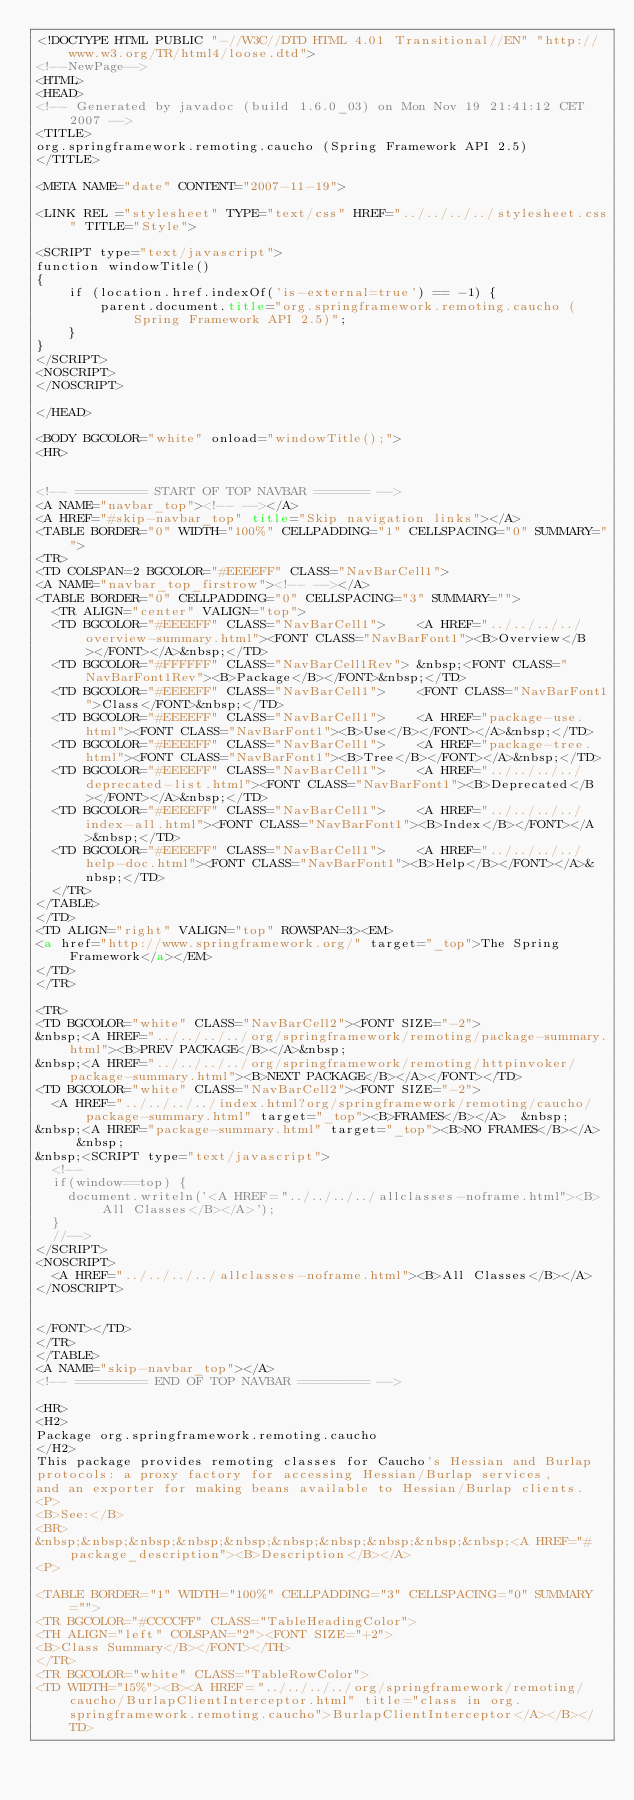<code> <loc_0><loc_0><loc_500><loc_500><_HTML_><!DOCTYPE HTML PUBLIC "-//W3C//DTD HTML 4.01 Transitional//EN" "http://www.w3.org/TR/html4/loose.dtd">
<!--NewPage-->
<HTML>
<HEAD>
<!-- Generated by javadoc (build 1.6.0_03) on Mon Nov 19 21:41:12 CET 2007 -->
<TITLE>
org.springframework.remoting.caucho (Spring Framework API 2.5)
</TITLE>

<META NAME="date" CONTENT="2007-11-19">

<LINK REL ="stylesheet" TYPE="text/css" HREF="../../../../stylesheet.css" TITLE="Style">

<SCRIPT type="text/javascript">
function windowTitle()
{
    if (location.href.indexOf('is-external=true') == -1) {
        parent.document.title="org.springframework.remoting.caucho (Spring Framework API 2.5)";
    }
}
</SCRIPT>
<NOSCRIPT>
</NOSCRIPT>

</HEAD>

<BODY BGCOLOR="white" onload="windowTitle();">
<HR>


<!-- ========= START OF TOP NAVBAR ======= -->
<A NAME="navbar_top"><!-- --></A>
<A HREF="#skip-navbar_top" title="Skip navigation links"></A>
<TABLE BORDER="0" WIDTH="100%" CELLPADDING="1" CELLSPACING="0" SUMMARY="">
<TR>
<TD COLSPAN=2 BGCOLOR="#EEEEFF" CLASS="NavBarCell1">
<A NAME="navbar_top_firstrow"><!-- --></A>
<TABLE BORDER="0" CELLPADDING="0" CELLSPACING="3" SUMMARY="">
  <TR ALIGN="center" VALIGN="top">
  <TD BGCOLOR="#EEEEFF" CLASS="NavBarCell1">    <A HREF="../../../../overview-summary.html"><FONT CLASS="NavBarFont1"><B>Overview</B></FONT></A>&nbsp;</TD>
  <TD BGCOLOR="#FFFFFF" CLASS="NavBarCell1Rev"> &nbsp;<FONT CLASS="NavBarFont1Rev"><B>Package</B></FONT>&nbsp;</TD>
  <TD BGCOLOR="#EEEEFF" CLASS="NavBarCell1">    <FONT CLASS="NavBarFont1">Class</FONT>&nbsp;</TD>
  <TD BGCOLOR="#EEEEFF" CLASS="NavBarCell1">    <A HREF="package-use.html"><FONT CLASS="NavBarFont1"><B>Use</B></FONT></A>&nbsp;</TD>
  <TD BGCOLOR="#EEEEFF" CLASS="NavBarCell1">    <A HREF="package-tree.html"><FONT CLASS="NavBarFont1"><B>Tree</B></FONT></A>&nbsp;</TD>
  <TD BGCOLOR="#EEEEFF" CLASS="NavBarCell1">    <A HREF="../../../../deprecated-list.html"><FONT CLASS="NavBarFont1"><B>Deprecated</B></FONT></A>&nbsp;</TD>
  <TD BGCOLOR="#EEEEFF" CLASS="NavBarCell1">    <A HREF="../../../../index-all.html"><FONT CLASS="NavBarFont1"><B>Index</B></FONT></A>&nbsp;</TD>
  <TD BGCOLOR="#EEEEFF" CLASS="NavBarCell1">    <A HREF="../../../../help-doc.html"><FONT CLASS="NavBarFont1"><B>Help</B></FONT></A>&nbsp;</TD>
  </TR>
</TABLE>
</TD>
<TD ALIGN="right" VALIGN="top" ROWSPAN=3><EM>
<a href="http://www.springframework.org/" target="_top">The Spring Framework</a></EM>
</TD>
</TR>

<TR>
<TD BGCOLOR="white" CLASS="NavBarCell2"><FONT SIZE="-2">
&nbsp;<A HREF="../../../../org/springframework/remoting/package-summary.html"><B>PREV PACKAGE</B></A>&nbsp;
&nbsp;<A HREF="../../../../org/springframework/remoting/httpinvoker/package-summary.html"><B>NEXT PACKAGE</B></A></FONT></TD>
<TD BGCOLOR="white" CLASS="NavBarCell2"><FONT SIZE="-2">
  <A HREF="../../../../index.html?org/springframework/remoting/caucho/package-summary.html" target="_top"><B>FRAMES</B></A>  &nbsp;
&nbsp;<A HREF="package-summary.html" target="_top"><B>NO FRAMES</B></A>  &nbsp;
&nbsp;<SCRIPT type="text/javascript">
  <!--
  if(window==top) {
    document.writeln('<A HREF="../../../../allclasses-noframe.html"><B>All Classes</B></A>');
  }
  //-->
</SCRIPT>
<NOSCRIPT>
  <A HREF="../../../../allclasses-noframe.html"><B>All Classes</B></A>
</NOSCRIPT>


</FONT></TD>
</TR>
</TABLE>
<A NAME="skip-navbar_top"></A>
<!-- ========= END OF TOP NAVBAR ========= -->

<HR>
<H2>
Package org.springframework.remoting.caucho
</H2>
This package provides remoting classes for Caucho's Hessian and Burlap
protocols: a proxy factory for accessing Hessian/Burlap services,
and an exporter for making beans available to Hessian/Burlap clients.
<P>
<B>See:</B>
<BR>
&nbsp;&nbsp;&nbsp;&nbsp;&nbsp;&nbsp;&nbsp;&nbsp;&nbsp;&nbsp;<A HREF="#package_description"><B>Description</B></A>
<P>

<TABLE BORDER="1" WIDTH="100%" CELLPADDING="3" CELLSPACING="0" SUMMARY="">
<TR BGCOLOR="#CCCCFF" CLASS="TableHeadingColor">
<TH ALIGN="left" COLSPAN="2"><FONT SIZE="+2">
<B>Class Summary</B></FONT></TH>
</TR>
<TR BGCOLOR="white" CLASS="TableRowColor">
<TD WIDTH="15%"><B><A HREF="../../../../org/springframework/remoting/caucho/BurlapClientInterceptor.html" title="class in org.springframework.remoting.caucho">BurlapClientInterceptor</A></B></TD></code> 